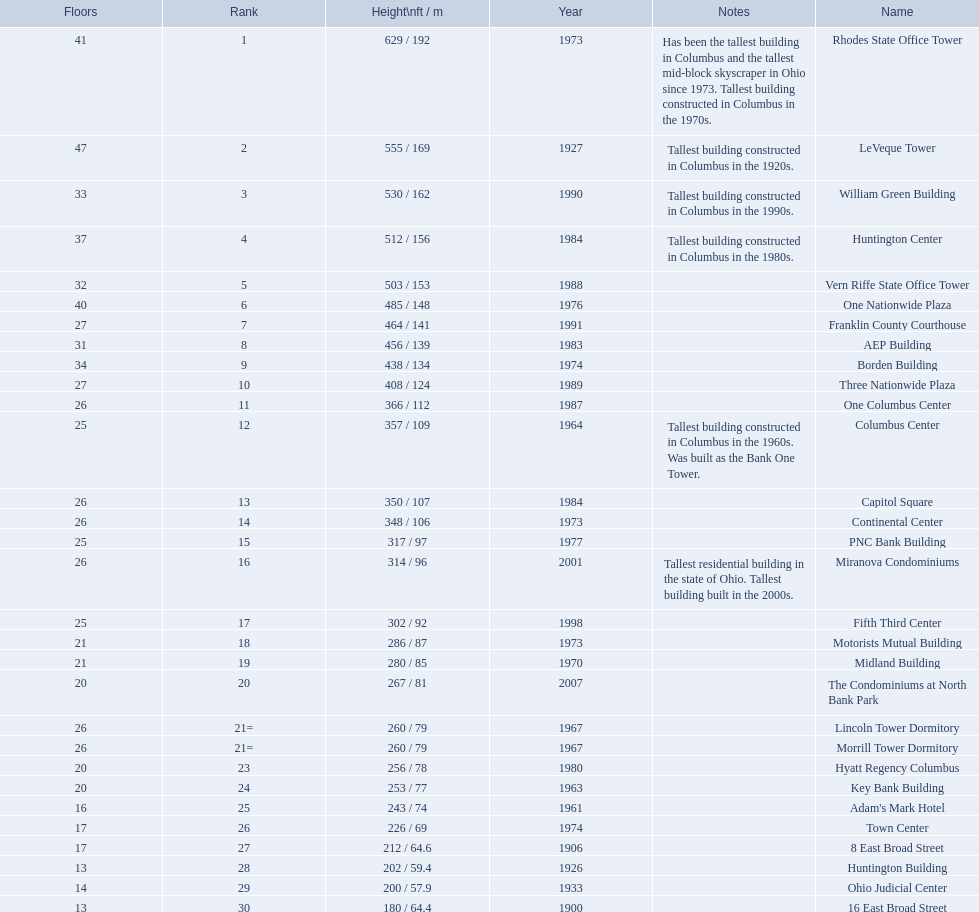How tall is the aep building? 456 / 139. How tall is the one columbus center? 366 / 112. Of these two buildings, which is taller? AEP Building. 